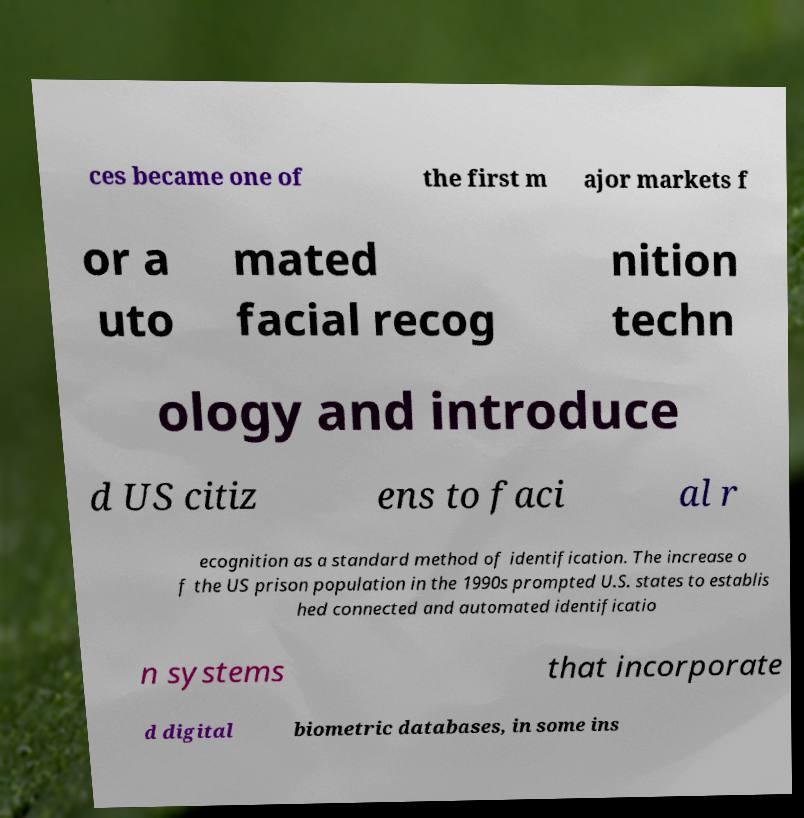What messages or text are displayed in this image? I need them in a readable, typed format. ces became one of the first m ajor markets f or a uto mated facial recog nition techn ology and introduce d US citiz ens to faci al r ecognition as a standard method of identification. The increase o f the US prison population in the 1990s prompted U.S. states to establis hed connected and automated identificatio n systems that incorporate d digital biometric databases, in some ins 